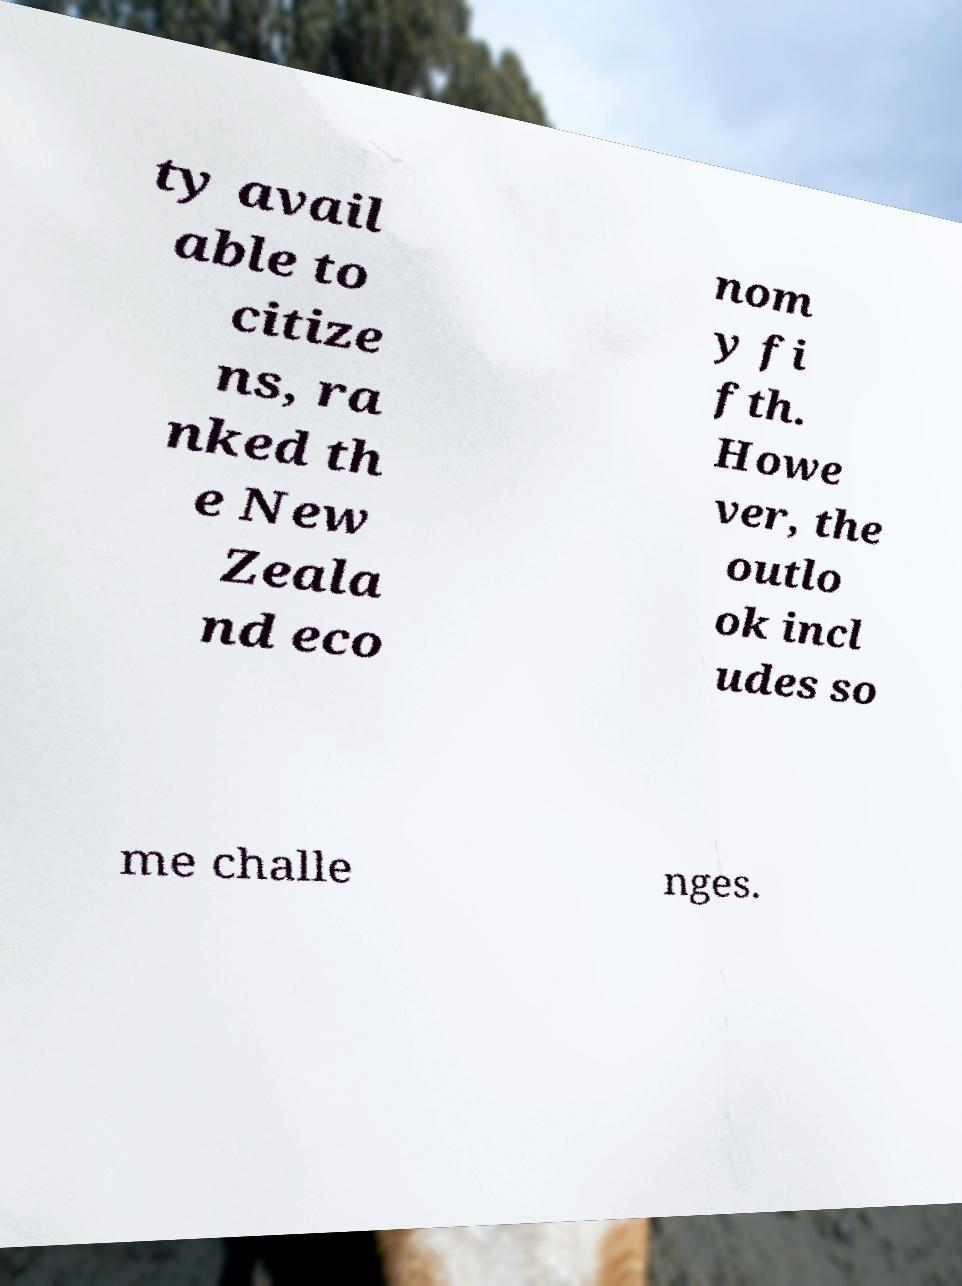Can you read and provide the text displayed in the image?This photo seems to have some interesting text. Can you extract and type it out for me? ty avail able to citize ns, ra nked th e New Zeala nd eco nom y fi fth. Howe ver, the outlo ok incl udes so me challe nges. 